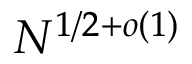Convert formula to latex. <formula><loc_0><loc_0><loc_500><loc_500>N ^ { 1 / 2 + o ( 1 ) }</formula> 